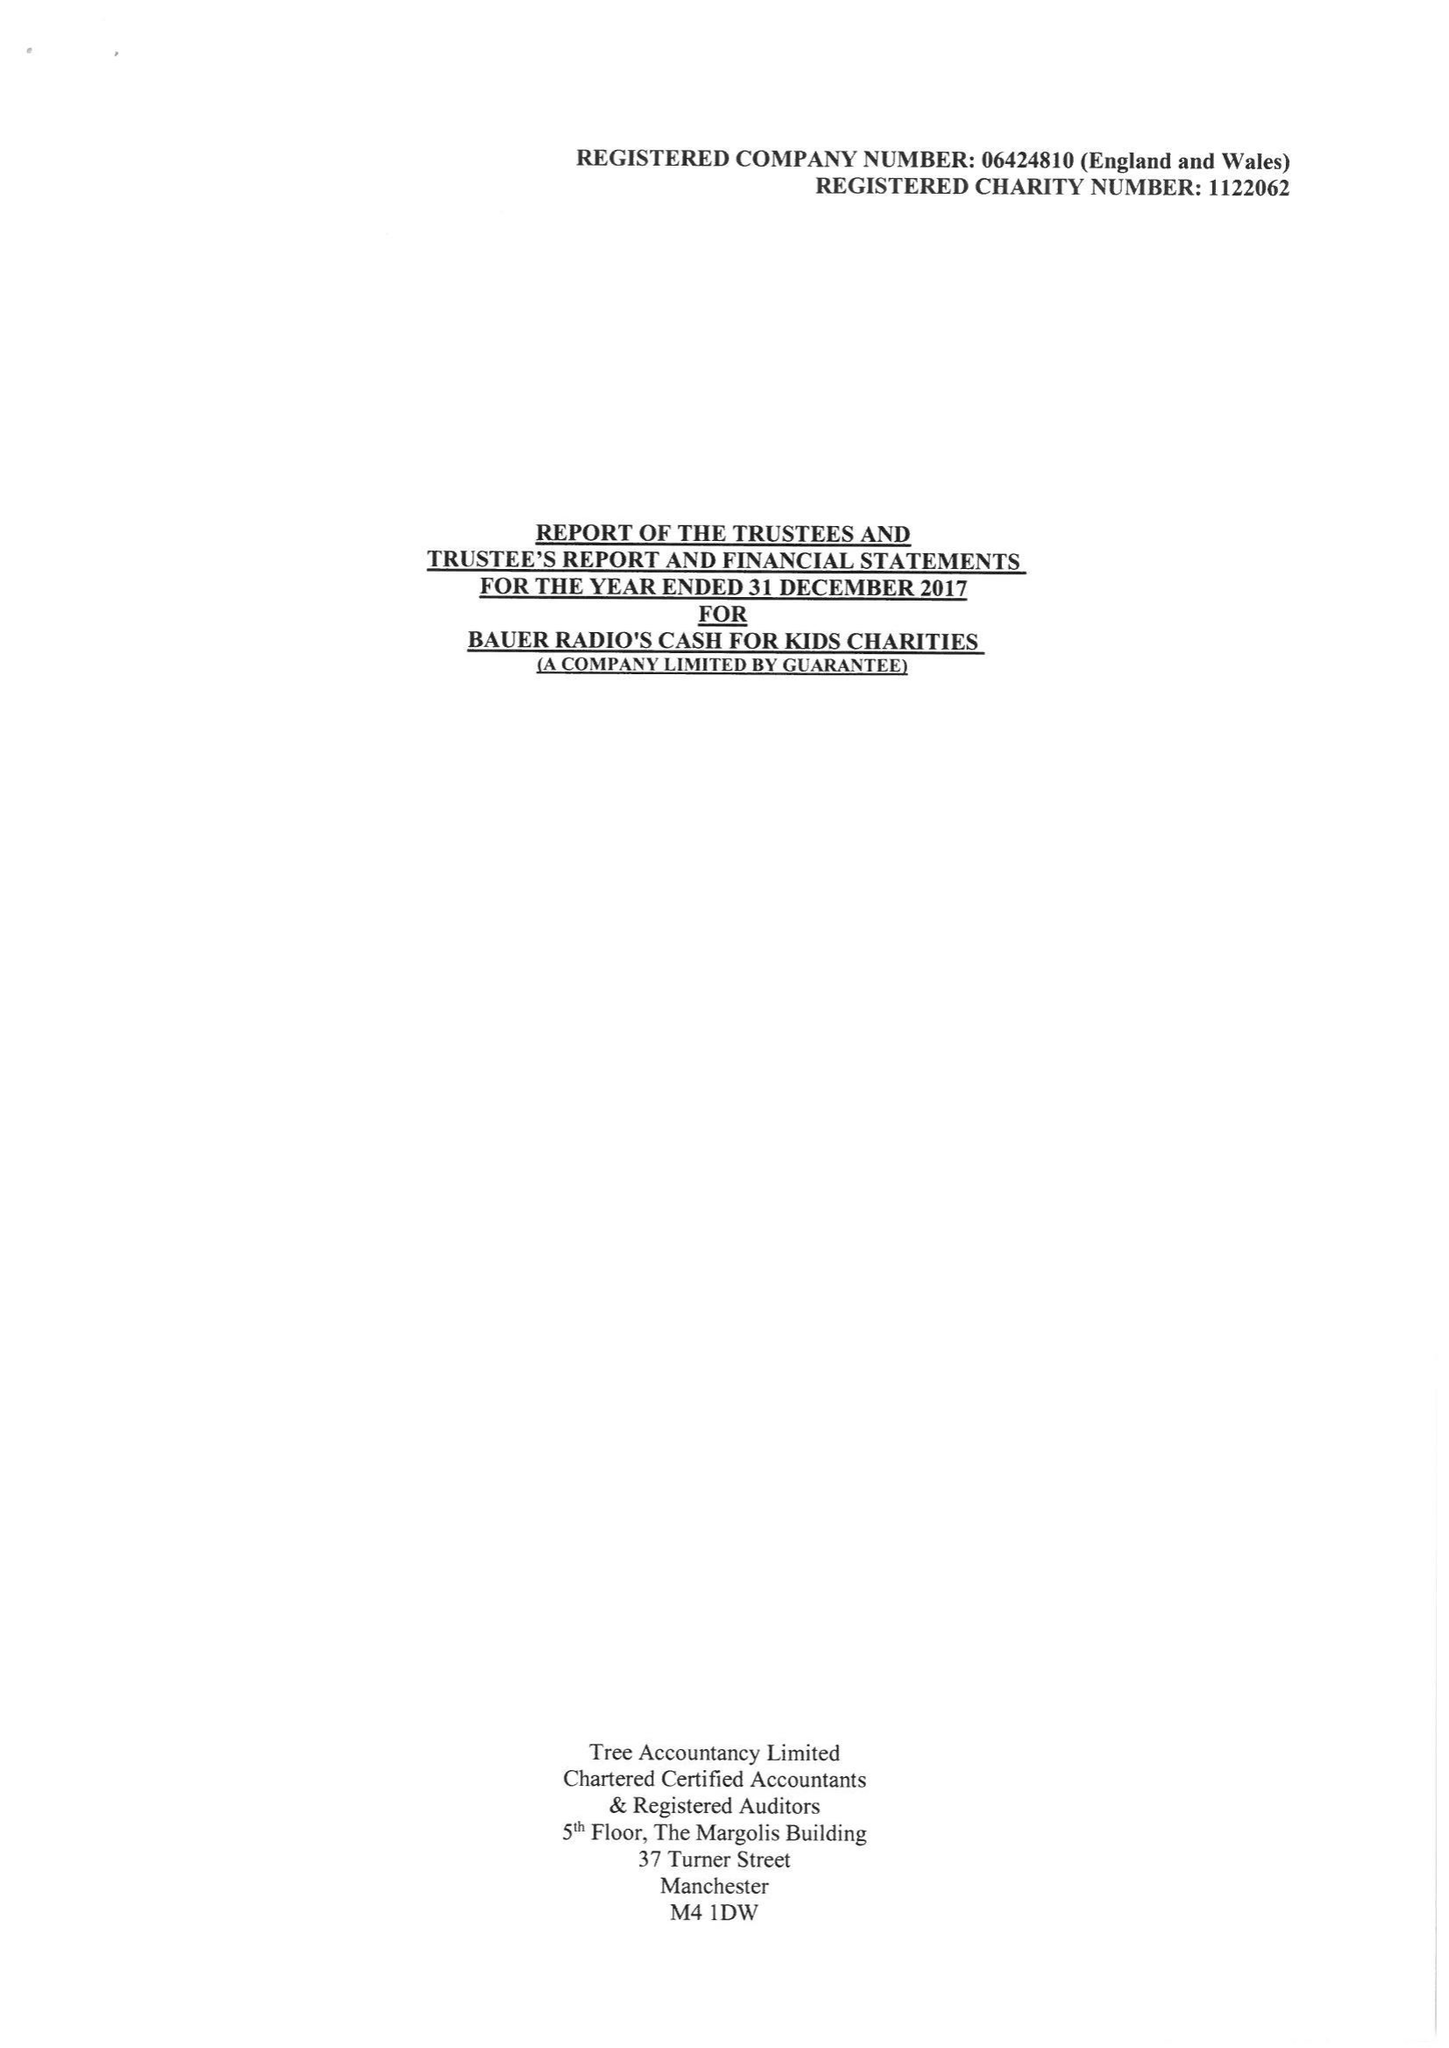What is the value for the address__post_town?
Answer the question using a single word or phrase. STOCKTON-ON-TEES 